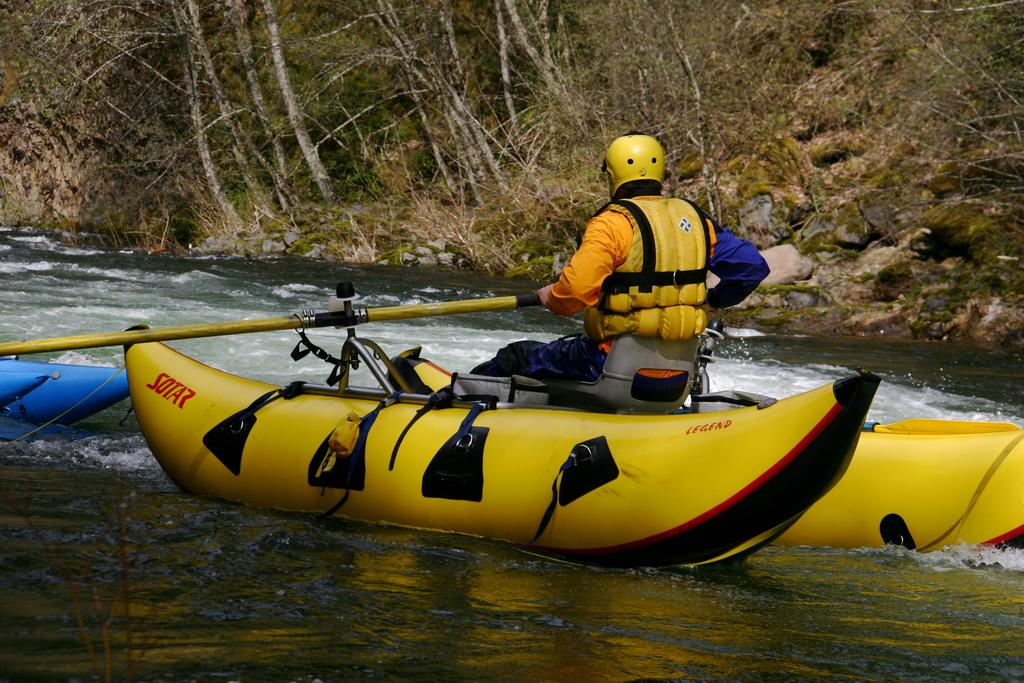<image>
Share a concise interpretation of the image provided. A man in a raft which has SOTA7 written on it. 